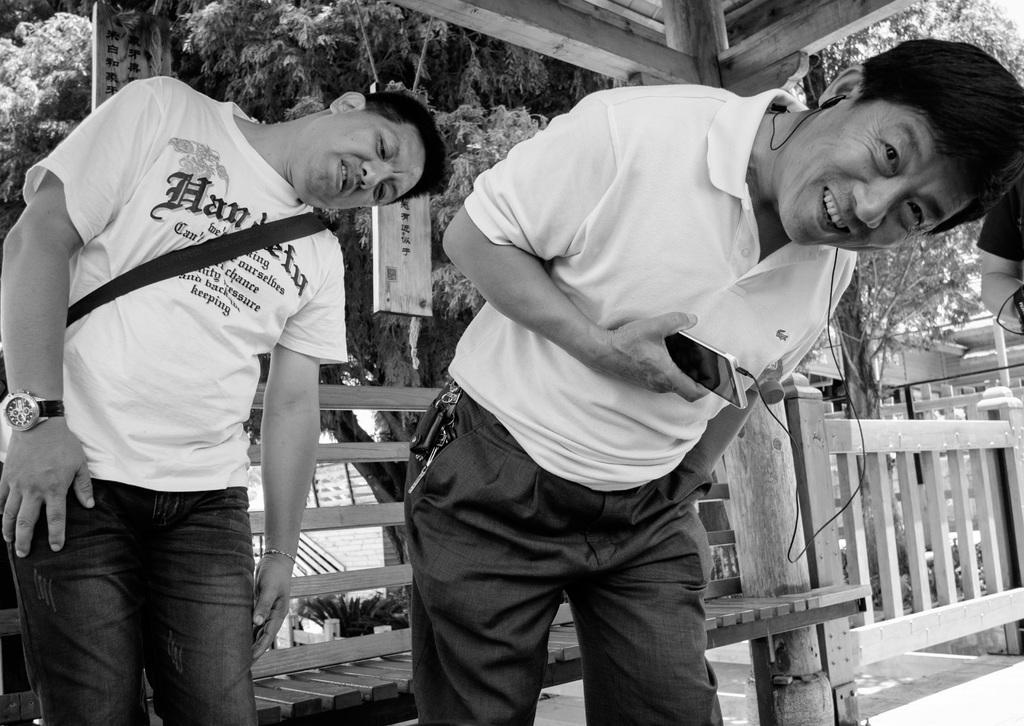How would you summarize this image in a sentence or two? In this picture there are two men wearing white t-shirt and standing in a front, smiling and giving a pose into the camera. Behind there is a wooden bench and fencing grill. In the background we can see some trees. 